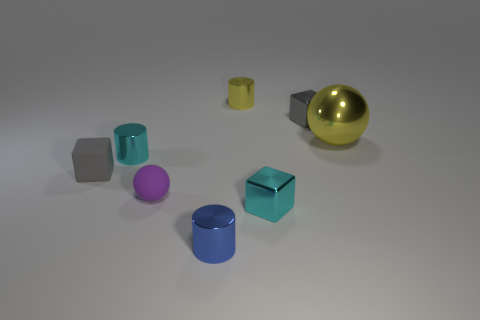Add 1 small blue metal objects. How many objects exist? 9 Subtract all cylinders. How many objects are left? 5 Subtract 1 gray cubes. How many objects are left? 7 Subtract all cyan things. Subtract all cyan metallic cubes. How many objects are left? 5 Add 6 balls. How many balls are left? 8 Add 7 small blue metallic things. How many small blue metallic things exist? 8 